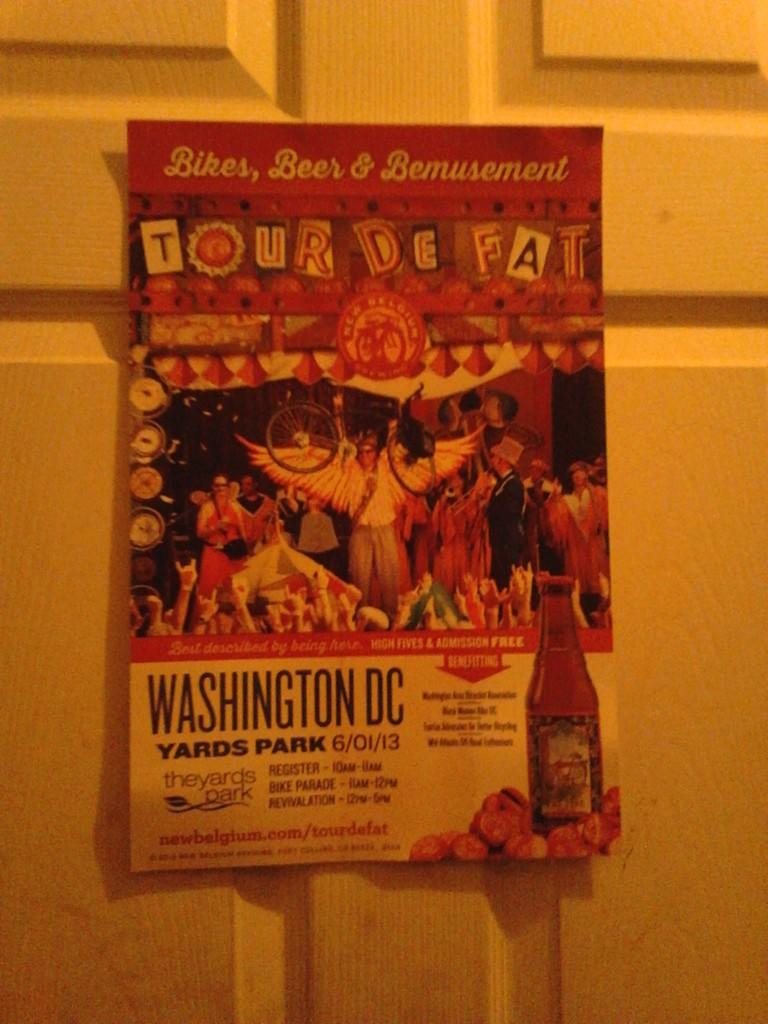<image>
Give a short and clear explanation of the subsequent image. A flyer for Tour De Fat at Washington's  Yards park is posted on a door. 